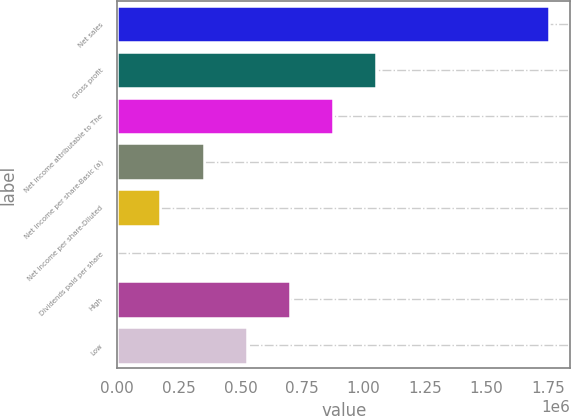<chart> <loc_0><loc_0><loc_500><loc_500><bar_chart><fcel>Net sales<fcel>Gross profit<fcel>Net income attributable to The<fcel>Net income per share-Basic (a)<fcel>Net income per share-Diluted<fcel>Dividends paid per share<fcel>High<fcel>Low<nl><fcel>1.75162e+06<fcel>1.05097e+06<fcel>875808<fcel>350324<fcel>175162<fcel>0.66<fcel>700646<fcel>525485<nl></chart> 